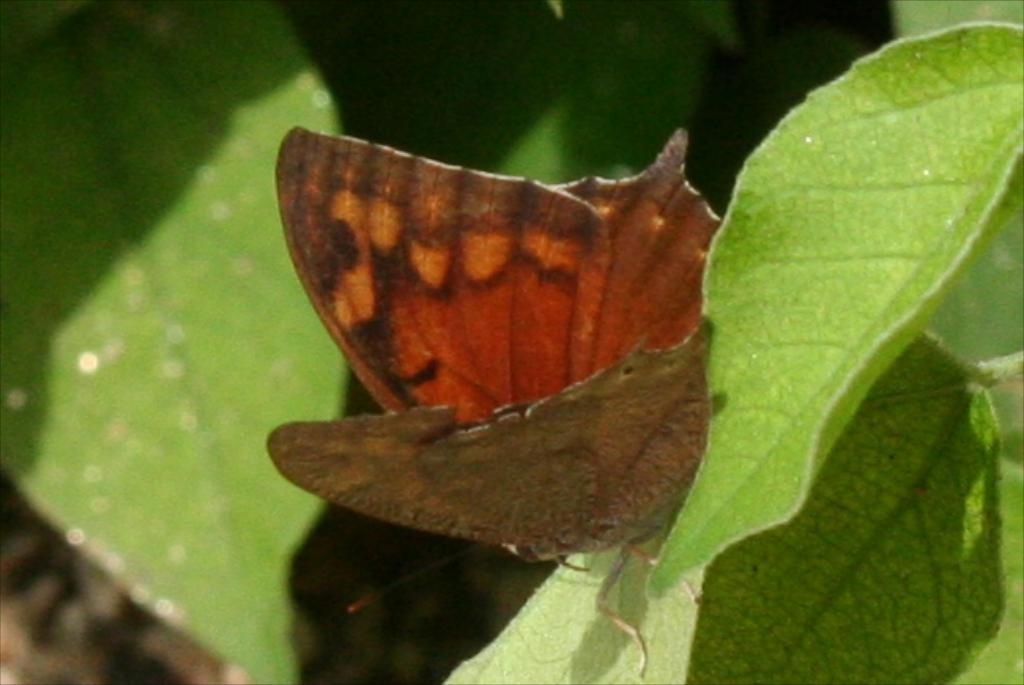What type of insect is in the image? There is a brown butterfly in the image. What is the butterfly resting on? The butterfly is on a leaf. Can you describe the background of the image? The background of the image is blurred. What type of bead is hanging from the butterfly's antennae in the image? There is no bead present on the butterfly's antennae in the image. How does the butterfly make its selection of leaves in the image? Butterflies do not make selections of leaves; they simply land on them. 